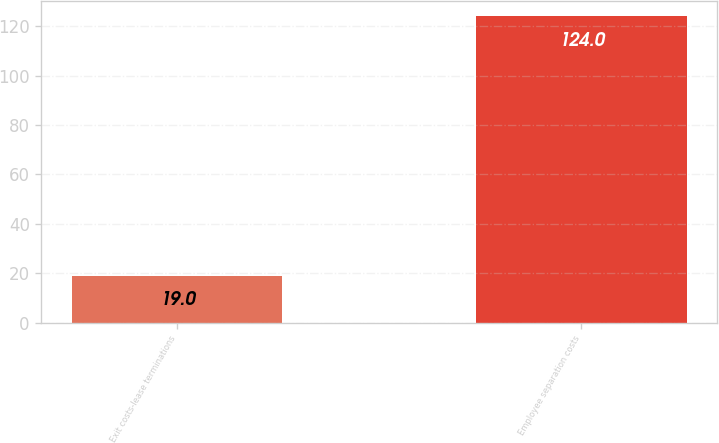<chart> <loc_0><loc_0><loc_500><loc_500><bar_chart><fcel>Exit costs-lease terminations<fcel>Employee separation costs<nl><fcel>19<fcel>124<nl></chart> 